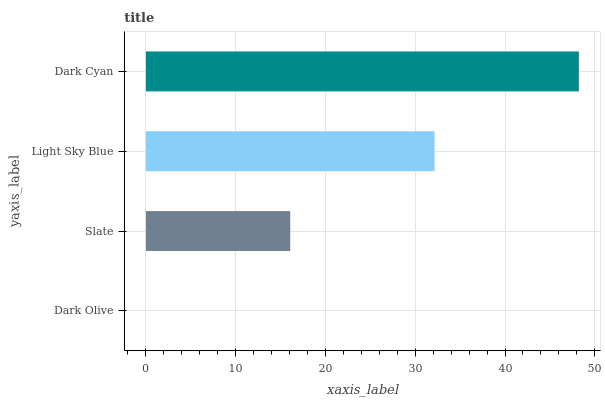Is Dark Olive the minimum?
Answer yes or no. Yes. Is Dark Cyan the maximum?
Answer yes or no. Yes. Is Slate the minimum?
Answer yes or no. No. Is Slate the maximum?
Answer yes or no. No. Is Slate greater than Dark Olive?
Answer yes or no. Yes. Is Dark Olive less than Slate?
Answer yes or no. Yes. Is Dark Olive greater than Slate?
Answer yes or no. No. Is Slate less than Dark Olive?
Answer yes or no. No. Is Light Sky Blue the high median?
Answer yes or no. Yes. Is Slate the low median?
Answer yes or no. Yes. Is Dark Cyan the high median?
Answer yes or no. No. Is Light Sky Blue the low median?
Answer yes or no. No. 